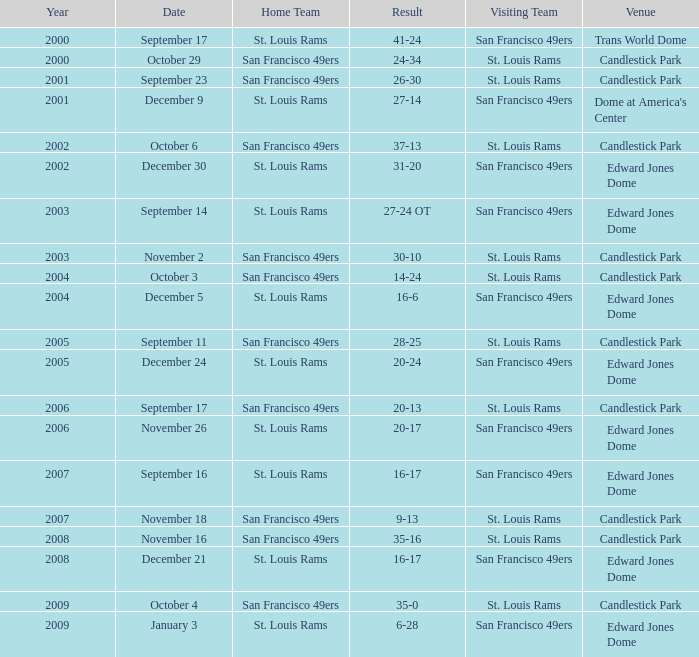What was the Venue of the San Francisco 49ers Home game with a Result of 30-10? Candlestick Park. 